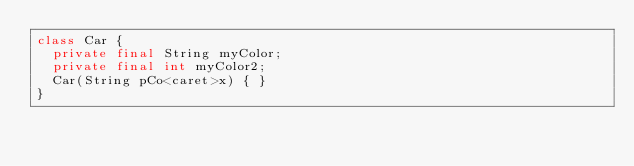Convert code to text. <code><loc_0><loc_0><loc_500><loc_500><_Java_>class Car {
  private final String myColor;
  private final int myColor2;
  Car(String pCo<caret>x) { }
}</code> 